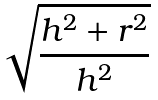Convert formula to latex. <formula><loc_0><loc_0><loc_500><loc_500>\sqrt { \frac { h ^ { 2 } + r ^ { 2 } } { h ^ { 2 } } }</formula> 